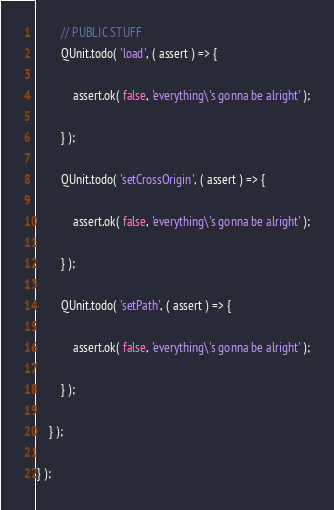Convert code to text. <code><loc_0><loc_0><loc_500><loc_500><_JavaScript_>		// PUBLIC STUFF
		QUnit.todo( 'load', ( assert ) => {

			assert.ok( false, 'everything\'s gonna be alright' );

		} );

		QUnit.todo( 'setCrossOrigin', ( assert ) => {

			assert.ok( false, 'everything\'s gonna be alright' );

		} );

		QUnit.todo( 'setPath', ( assert ) => {

			assert.ok( false, 'everything\'s gonna be alright' );

		} );

	} );

} );
</code> 